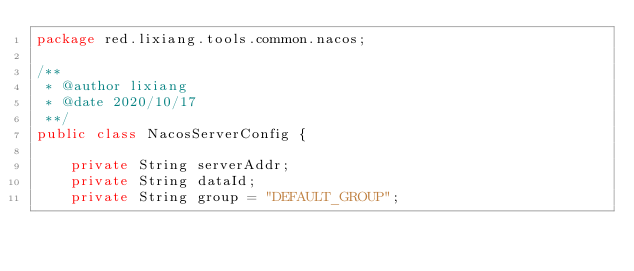Convert code to text. <code><loc_0><loc_0><loc_500><loc_500><_Java_>package red.lixiang.tools.common.nacos;

/**
 * @author lixiang
 * @date 2020/10/17
 **/
public class NacosServerConfig {

    private String serverAddr;
    private String dataId;
    private String group = "DEFAULT_GROUP";
</code> 